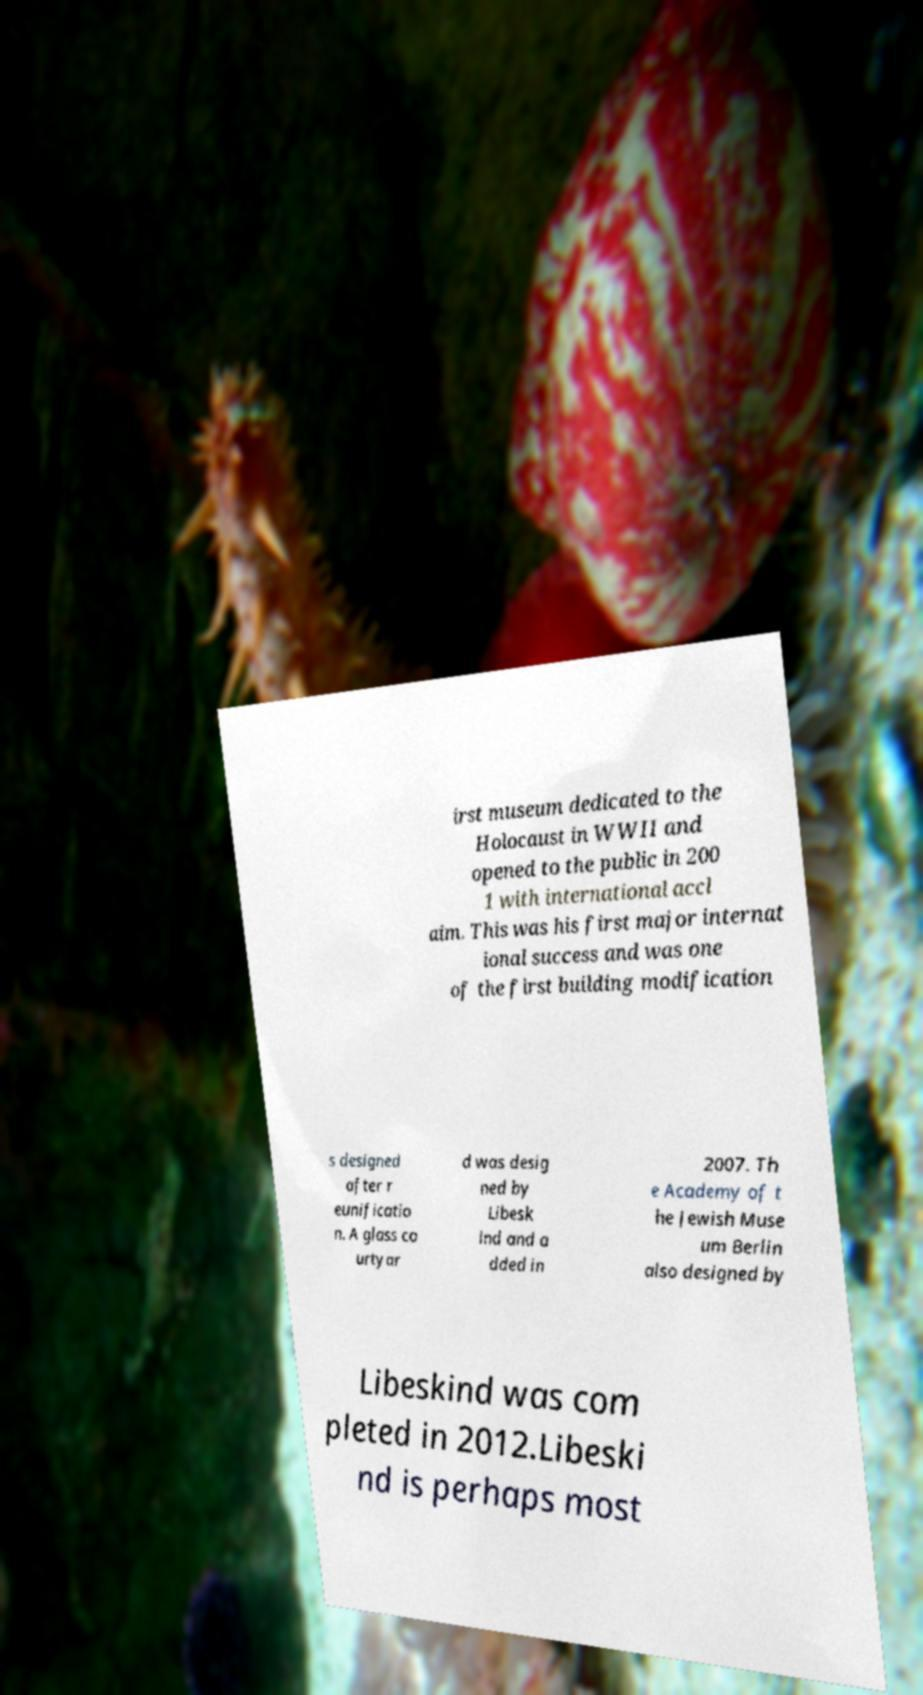Please read and relay the text visible in this image. What does it say? irst museum dedicated to the Holocaust in WWII and opened to the public in 200 1 with international accl aim. This was his first major internat ional success and was one of the first building modification s designed after r eunificatio n. A glass co urtyar d was desig ned by Libesk ind and a dded in 2007. Th e Academy of t he Jewish Muse um Berlin also designed by Libeskind was com pleted in 2012.Libeski nd is perhaps most 